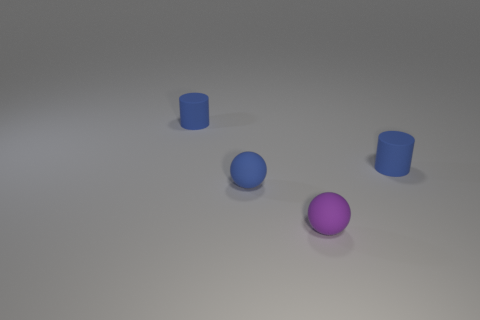How many blue cylinders must be subtracted to get 1 blue cylinders? 1 Add 1 purple balls. How many objects exist? 5 Subtract 1 spheres. How many spheres are left? 1 Add 3 tiny blue rubber balls. How many tiny blue rubber balls exist? 4 Subtract all blue spheres. How many spheres are left? 1 Subtract 0 cyan blocks. How many objects are left? 4 Subtract all purple spheres. Subtract all yellow cylinders. How many spheres are left? 1 Subtract all brown spheres. How many green cylinders are left? 0 Subtract all gray shiny objects. Subtract all tiny cylinders. How many objects are left? 2 Add 4 blue things. How many blue things are left? 7 